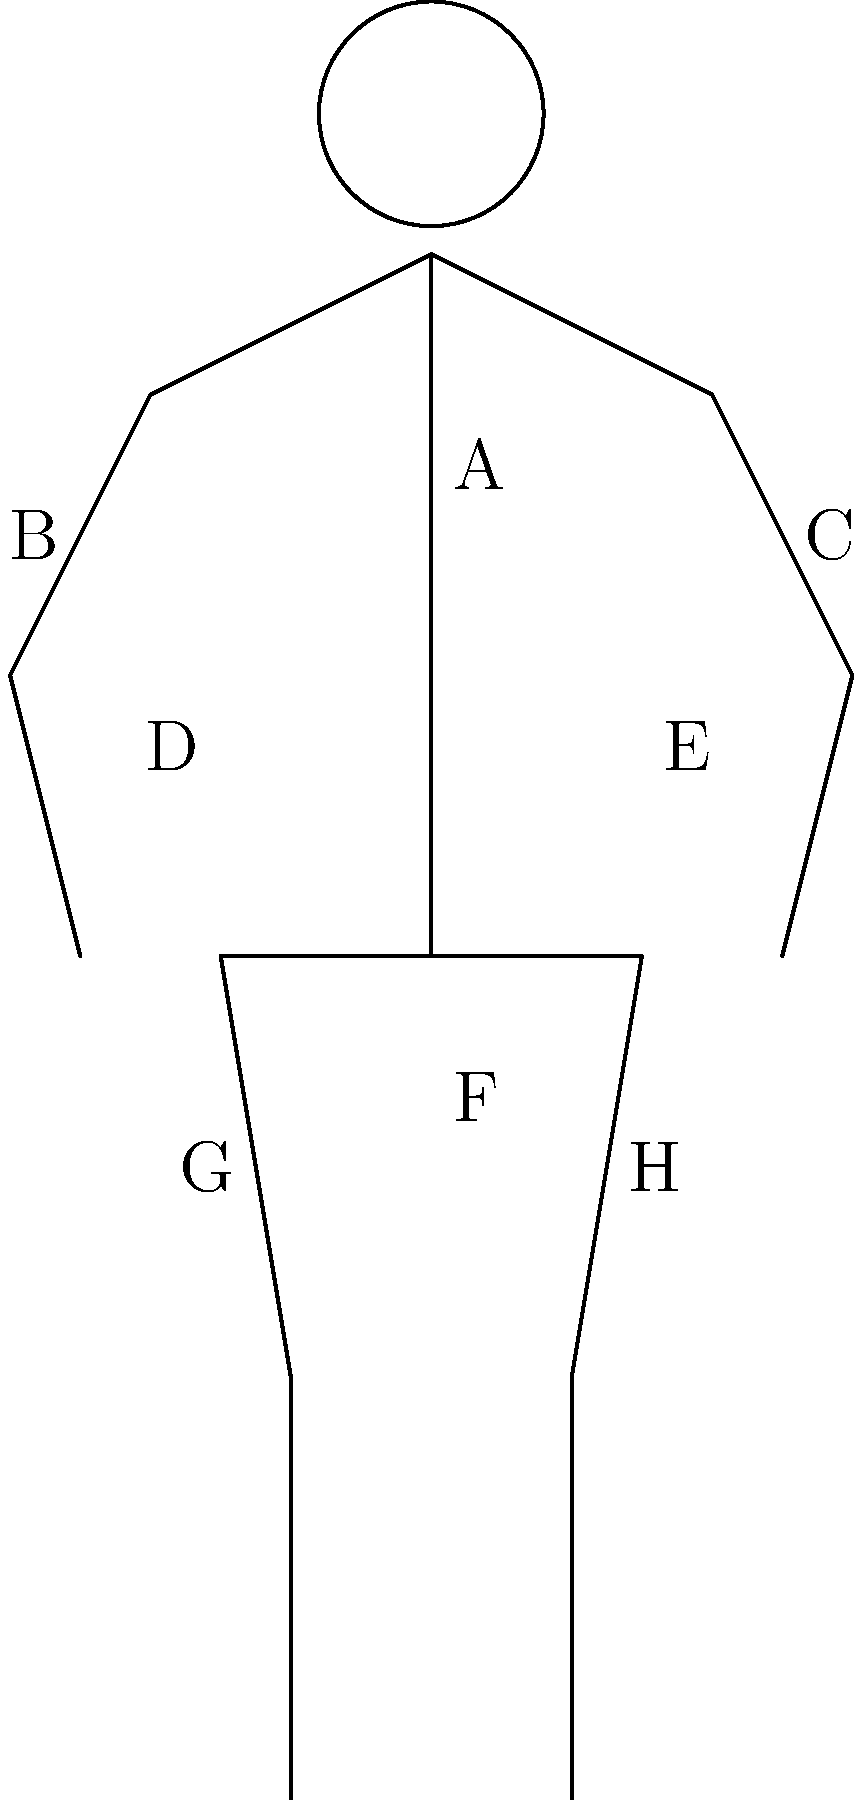As a competitive bodybuilder, you know the importance of targeting specific muscle groups during training. Identify the muscle group labeled "F" in the diagram above. To correctly identify the muscle group labeled "F" in the diagram, let's go through the process of elimination:

1. The diagram shows a simplified human anatomy with labeled muscle groups.
2. Label "F" is positioned in the center of the torso, just below the chest area.
3. This location corresponds to the abdominal muscles, also known as the "abs" or "core" in bodybuilding terminology.
4. The abdominal muscles are crucial for maintaining stability during lifts and are often a focus in bodybuilding aesthetics.
5. Other labeled areas can be identified as follows:
   A: Trapezius (upper back)
   B and C: Deltoids (shoulders)
   D and E: Pectorals (chest)
   G and H: Quadriceps (front thigh)

Given the position of label "F" and its importance in bodybuilding, the correct identification is the abdominal muscles.
Answer: Abdominal muscles 